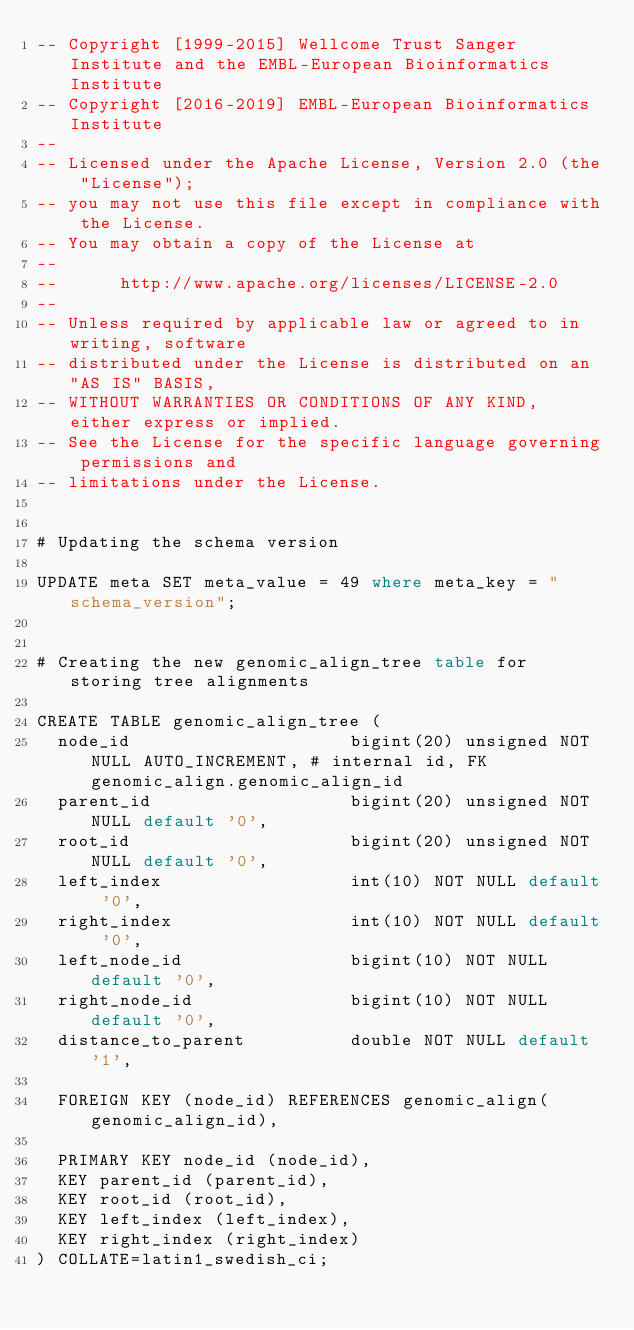<code> <loc_0><loc_0><loc_500><loc_500><_SQL_>-- Copyright [1999-2015] Wellcome Trust Sanger Institute and the EMBL-European Bioinformatics Institute
-- Copyright [2016-2019] EMBL-European Bioinformatics Institute
-- 
-- Licensed under the Apache License, Version 2.0 (the "License");
-- you may not use this file except in compliance with the License.
-- You may obtain a copy of the License at
-- 
--      http://www.apache.org/licenses/LICENSE-2.0
-- 
-- Unless required by applicable law or agreed to in writing, software
-- distributed under the License is distributed on an "AS IS" BASIS,
-- WITHOUT WARRANTIES OR CONDITIONS OF ANY KIND, either express or implied.
-- See the License for the specific language governing permissions and
-- limitations under the License.


# Updating the schema version

UPDATE meta SET meta_value = 49 where meta_key = "schema_version";


# Creating the new genomic_align_tree table for storing tree alignments

CREATE TABLE genomic_align_tree (
  node_id                     bigint(20) unsigned NOT NULL AUTO_INCREMENT, # internal id, FK genomic_align.genomic_align_id
  parent_id                   bigint(20) unsigned NOT NULL default '0',
  root_id                     bigint(20) unsigned NOT NULL default '0',
  left_index                  int(10) NOT NULL default '0',
  right_index                 int(10) NOT NULL default '0',
  left_node_id                bigint(10) NOT NULL default '0',
  right_node_id               bigint(10) NOT NULL default '0',
  distance_to_parent          double NOT NULL default '1',

  FOREIGN KEY (node_id) REFERENCES genomic_align(genomic_align_id),

  PRIMARY KEY node_id (node_id),
  KEY parent_id (parent_id),
  KEY root_id (root_id),
  KEY left_index (left_index),
  KEY right_index (right_index)
) COLLATE=latin1_swedish_ci;
</code> 